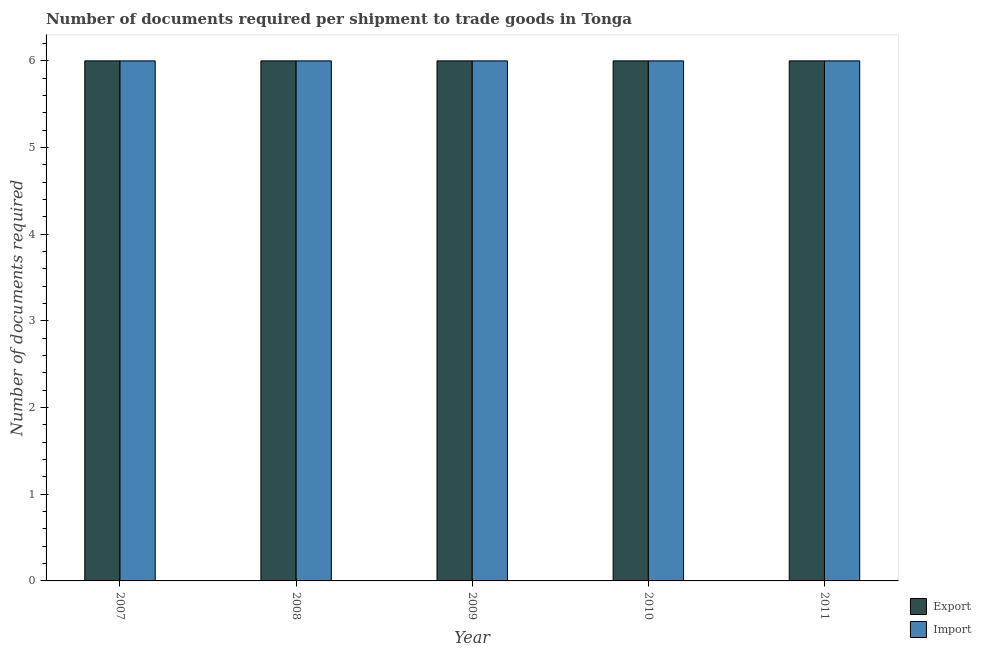How many bars are there on the 4th tick from the left?
Provide a short and direct response. 2. How many bars are there on the 2nd tick from the right?
Offer a very short reply. 2. What is the label of the 2nd group of bars from the left?
Offer a terse response. 2008. In how many cases, is the number of bars for a given year not equal to the number of legend labels?
Keep it short and to the point. 0. Across all years, what is the maximum number of documents required to import goods?
Keep it short and to the point. 6. What is the total number of documents required to export goods in the graph?
Ensure brevity in your answer.  30. What is the difference between the number of documents required to import goods in 2010 and that in 2011?
Provide a succinct answer. 0. Is the number of documents required to import goods in 2007 less than that in 2009?
Offer a very short reply. No. What is the difference between the highest and the second highest number of documents required to export goods?
Give a very brief answer. 0. In how many years, is the number of documents required to import goods greater than the average number of documents required to import goods taken over all years?
Give a very brief answer. 0. Is the sum of the number of documents required to export goods in 2008 and 2010 greater than the maximum number of documents required to import goods across all years?
Your answer should be very brief. Yes. What does the 1st bar from the left in 2009 represents?
Provide a succinct answer. Export. What does the 1st bar from the right in 2008 represents?
Give a very brief answer. Import. How many bars are there?
Your answer should be compact. 10. Are all the bars in the graph horizontal?
Your response must be concise. No. What is the difference between two consecutive major ticks on the Y-axis?
Offer a terse response. 1. How many legend labels are there?
Give a very brief answer. 2. What is the title of the graph?
Offer a very short reply. Number of documents required per shipment to trade goods in Tonga. Does "Electricity" appear as one of the legend labels in the graph?
Ensure brevity in your answer.  No. What is the label or title of the Y-axis?
Your response must be concise. Number of documents required. What is the Number of documents required in Export in 2007?
Give a very brief answer. 6. What is the Number of documents required in Import in 2007?
Give a very brief answer. 6. What is the Number of documents required of Import in 2008?
Provide a short and direct response. 6. What is the Number of documents required of Export in 2010?
Your response must be concise. 6. What is the Number of documents required of Import in 2010?
Provide a short and direct response. 6. Across all years, what is the maximum Number of documents required of Export?
Make the answer very short. 6. Across all years, what is the maximum Number of documents required in Import?
Provide a succinct answer. 6. Across all years, what is the minimum Number of documents required in Export?
Provide a short and direct response. 6. What is the total Number of documents required in Export in the graph?
Provide a succinct answer. 30. What is the difference between the Number of documents required in Export in 2007 and that in 2008?
Offer a terse response. 0. What is the difference between the Number of documents required of Import in 2007 and that in 2009?
Your response must be concise. 0. What is the difference between the Number of documents required of Export in 2007 and that in 2010?
Offer a terse response. 0. What is the difference between the Number of documents required of Import in 2008 and that in 2010?
Provide a succinct answer. 0. What is the difference between the Number of documents required in Import in 2008 and that in 2011?
Provide a short and direct response. 0. What is the difference between the Number of documents required in Export in 2009 and that in 2010?
Keep it short and to the point. 0. What is the difference between the Number of documents required of Export in 2009 and that in 2011?
Provide a short and direct response. 0. What is the difference between the Number of documents required of Import in 2009 and that in 2011?
Your answer should be very brief. 0. What is the difference between the Number of documents required in Import in 2010 and that in 2011?
Provide a short and direct response. 0. What is the difference between the Number of documents required of Export in 2009 and the Number of documents required of Import in 2011?
Give a very brief answer. 0. What is the difference between the Number of documents required of Export in 2010 and the Number of documents required of Import in 2011?
Give a very brief answer. 0. In the year 2007, what is the difference between the Number of documents required in Export and Number of documents required in Import?
Offer a terse response. 0. What is the ratio of the Number of documents required in Export in 2007 to that in 2008?
Your response must be concise. 1. What is the ratio of the Number of documents required of Import in 2007 to that in 2008?
Provide a succinct answer. 1. What is the ratio of the Number of documents required in Export in 2007 to that in 2009?
Make the answer very short. 1. What is the ratio of the Number of documents required in Import in 2007 to that in 2009?
Keep it short and to the point. 1. What is the ratio of the Number of documents required in Export in 2007 to that in 2010?
Your answer should be very brief. 1. What is the ratio of the Number of documents required in Export in 2007 to that in 2011?
Give a very brief answer. 1. What is the ratio of the Number of documents required in Import in 2008 to that in 2010?
Provide a succinct answer. 1. What is the ratio of the Number of documents required of Export in 2008 to that in 2011?
Your answer should be compact. 1. What is the difference between the highest and the second highest Number of documents required of Export?
Provide a short and direct response. 0. What is the difference between the highest and the lowest Number of documents required in Import?
Give a very brief answer. 0. 